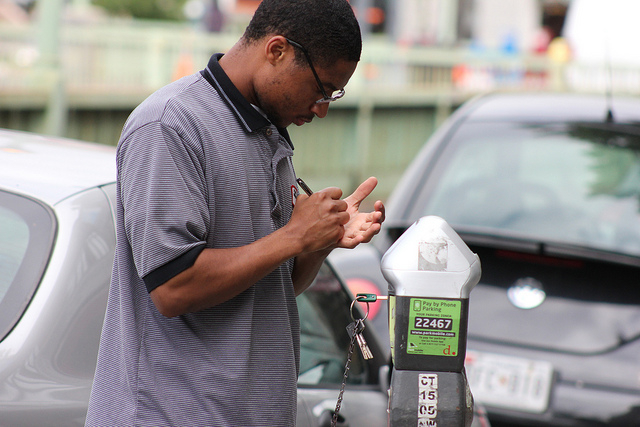Read all the text in this image. 22467 05 15 CT 